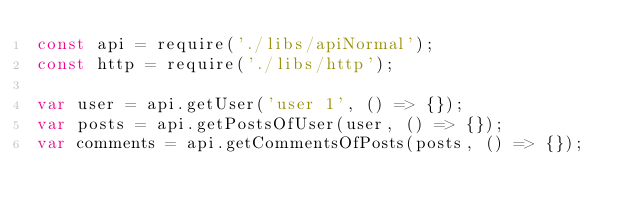<code> <loc_0><loc_0><loc_500><loc_500><_JavaScript_>const api = require('./libs/apiNormal');
const http = require('./libs/http');

var user = api.getUser('user 1', () => {});
var posts = api.getPostsOfUser(user, () => {});
var comments = api.getCommentsOfPosts(posts, () => {});</code> 